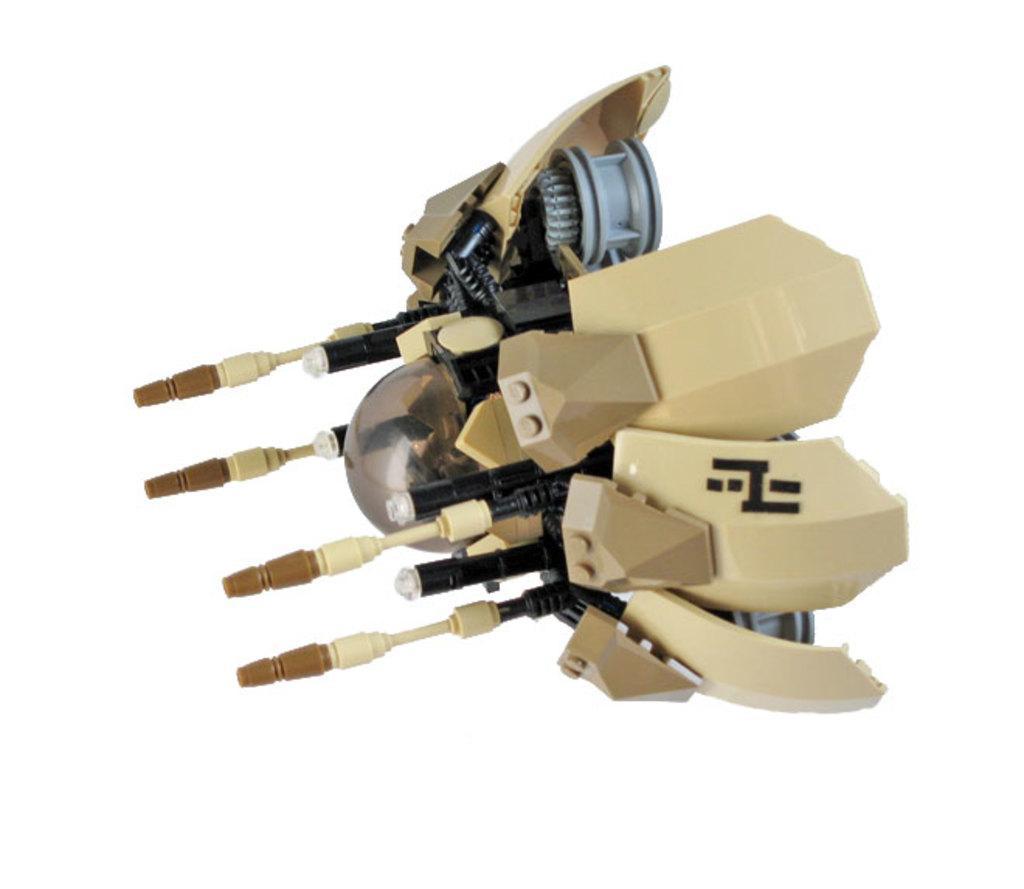In one or two sentences, can you explain what this image depicts? In this image there is a toy which is made with plastic. 